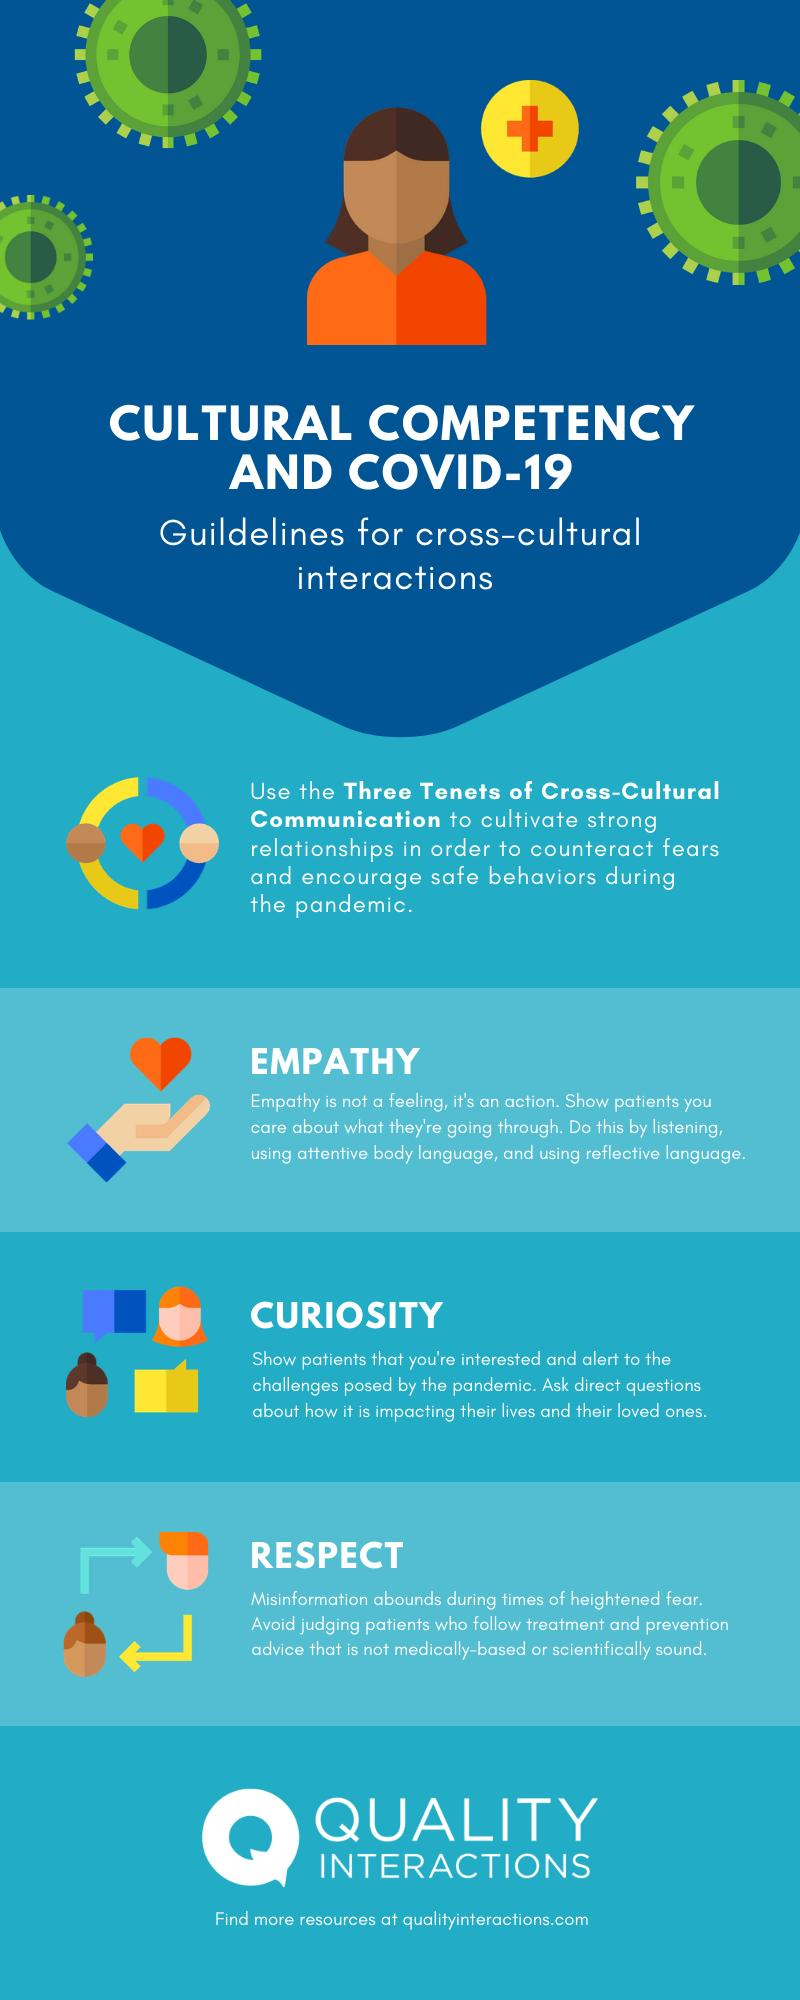Indicate a few pertinent items in this graphic. The three tenets of cross-cultural communication are empathy, curiosity, and respect, which are essential for effective communication across cultures and have the power to foster mutual understanding and respect among individuals and communities. 